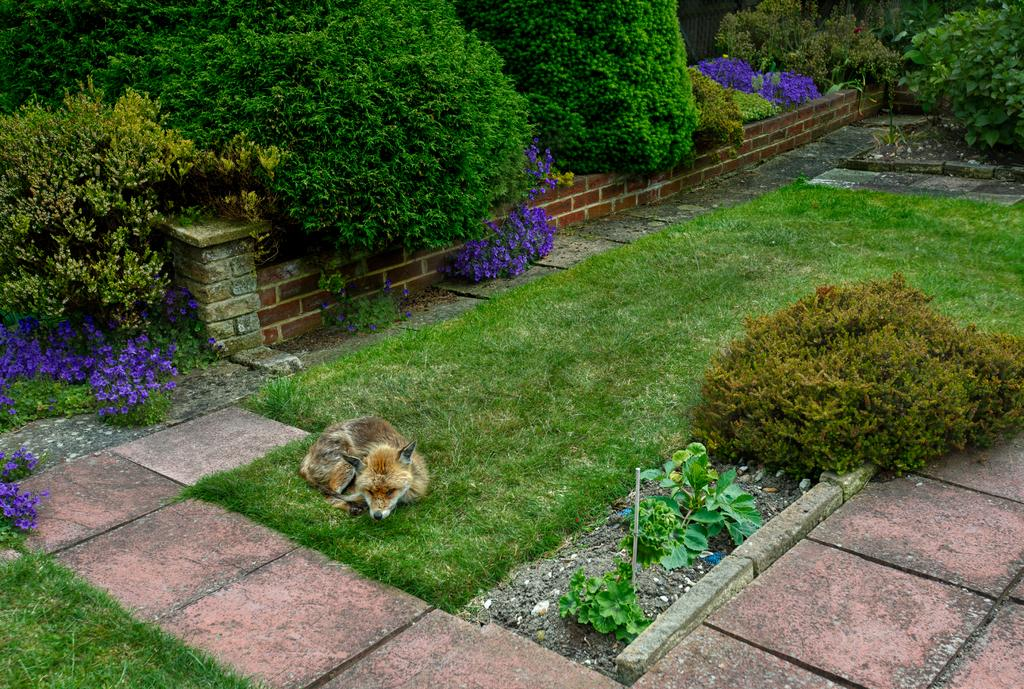What type of animal can be seen on the ground in the image? There is a dog on the ground in the image. What type of vegetation is visible in the image? There is grass and a group of plants visible in the image. Are there any plants with flowers in the image? Yes, there are plants with flowers in the image. What other elements can be seen in the image? There are stones, a wall, and a pathway in the image. What type of operation is the dog performing on the flowers in the image? There is no operation being performed by the dog in the image; it is simply sitting on the ground. 